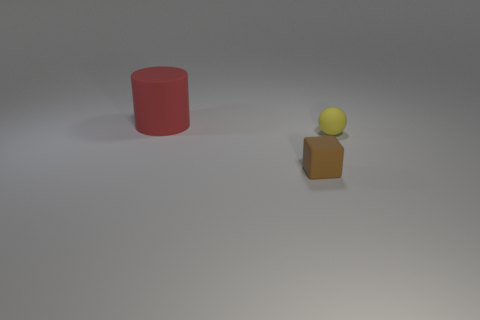Add 2 tiny yellow matte spheres. How many objects exist? 5 Subtract all spheres. How many objects are left? 2 Subtract 1 blocks. How many blocks are left? 0 Subtract all green balls. Subtract all yellow cubes. How many balls are left? 1 Subtract all purple balls. How many brown cylinders are left? 0 Subtract all yellow objects. Subtract all red cylinders. How many objects are left? 1 Add 2 large red cylinders. How many large red cylinders are left? 3 Add 3 large yellow metallic blocks. How many large yellow metallic blocks exist? 3 Subtract 0 cyan cylinders. How many objects are left? 3 